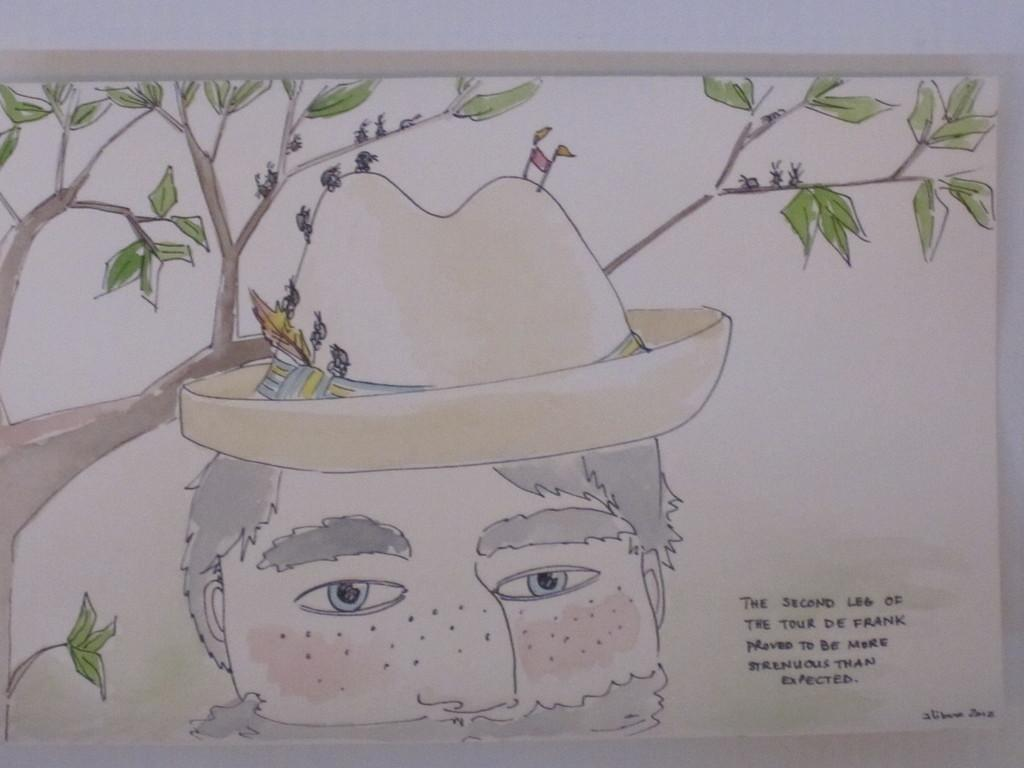What is depicted in the painting in the image? There is a painting of a person's face in the image. What is the person in the painting wearing? The person in the painting is wearing a hat. What is on the hat in the painting? There are ants on the hat on the hat in the painting. What are the ants doing in the painting? The ants are walking and climbing in the painting. What can be seen in the background of the painting? There is a tree in the background of the painting. What type of pies are being served at the feast in the image? There is no feast or pies present in the image; it features a painting of a person's face with ants on a hat. What is the wax used for in the image? There is no wax present in the image. 